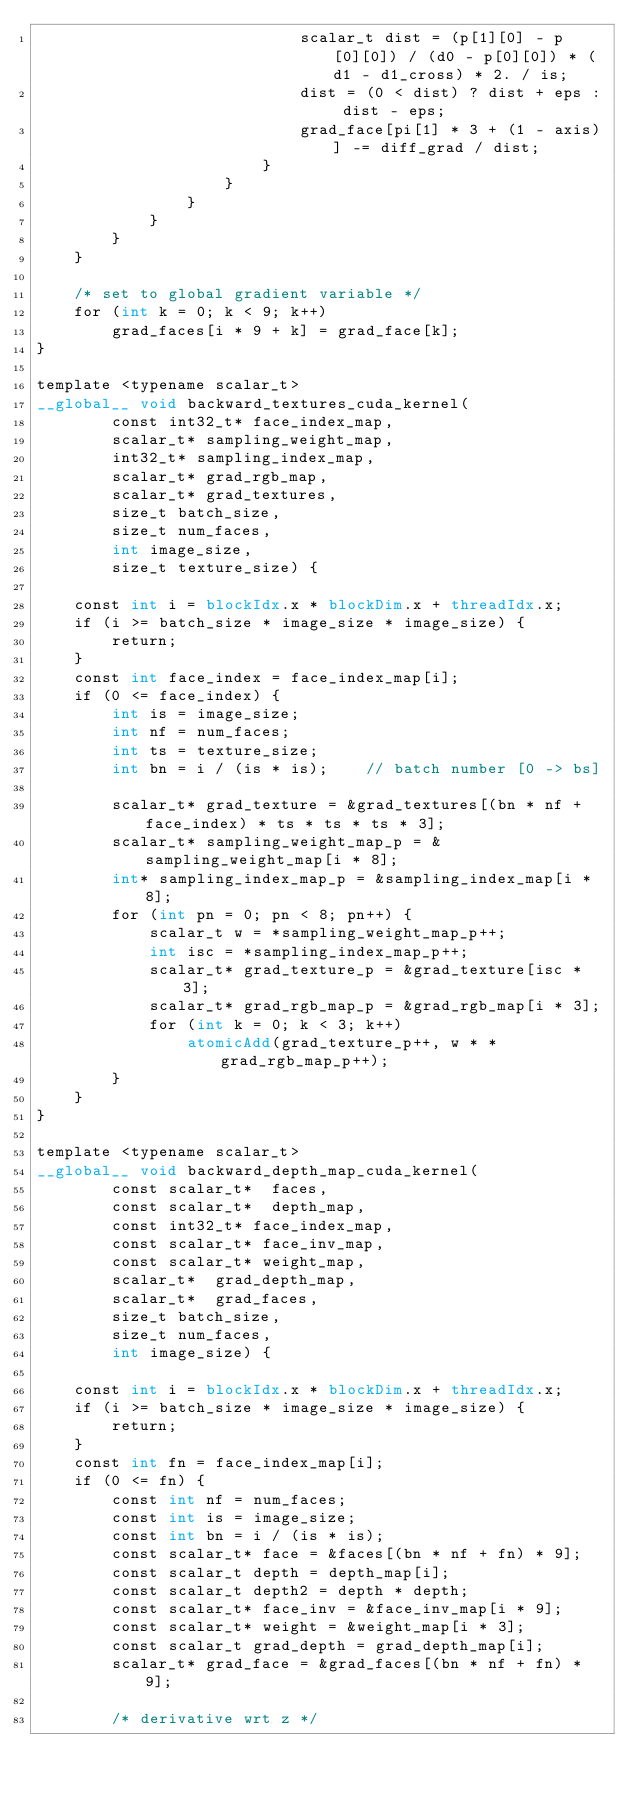<code> <loc_0><loc_0><loc_500><loc_500><_Cuda_>                            scalar_t dist = (p[1][0] - p[0][0]) / (d0 - p[0][0]) * (d1 - d1_cross) * 2. / is;
                            dist = (0 < dist) ? dist + eps : dist - eps;
                            grad_face[pi[1] * 3 + (1 - axis)] -= diff_grad / dist;
                        }
                    }
                }
            }
        }
    }

    /* set to global gradient variable */
    for (int k = 0; k < 9; k++)
        grad_faces[i * 9 + k] = grad_face[k];
}

template <typename scalar_t>
__global__ void backward_textures_cuda_kernel(
        const int32_t* face_index_map,
        scalar_t* sampling_weight_map,
        int32_t* sampling_index_map,
        scalar_t* grad_rgb_map,
        scalar_t* grad_textures,
        size_t batch_size,
        size_t num_faces,
        int image_size,
        size_t texture_size) {

    const int i = blockIdx.x * blockDim.x + threadIdx.x;
    if (i >= batch_size * image_size * image_size) {
        return;
    }
    const int face_index = face_index_map[i];
    if (0 <= face_index) {
        int is = image_size;
        int nf = num_faces;
        int ts = texture_size;
        int bn = i / (is * is);    // batch number [0 -> bs]
    
        scalar_t* grad_texture = &grad_textures[(bn * nf + face_index) * ts * ts * ts * 3];
        scalar_t* sampling_weight_map_p = &sampling_weight_map[i * 8];
        int* sampling_index_map_p = &sampling_index_map[i * 8];
        for (int pn = 0; pn < 8; pn++) {
            scalar_t w = *sampling_weight_map_p++;
            int isc = *sampling_index_map_p++;
            scalar_t* grad_texture_p = &grad_texture[isc * 3];
            scalar_t* grad_rgb_map_p = &grad_rgb_map[i * 3];
            for (int k = 0; k < 3; k++)
                atomicAdd(grad_texture_p++, w * *grad_rgb_map_p++);
        }
    }
}

template <typename scalar_t>
__global__ void backward_depth_map_cuda_kernel(
        const scalar_t*  faces,
        const scalar_t*  depth_map,
        const int32_t* face_index_map,
        const scalar_t* face_inv_map,
        const scalar_t* weight_map,
        scalar_t*  grad_depth_map,
        scalar_t*  grad_faces,
        size_t batch_size,
        size_t num_faces,
        int image_size) {
    
    const int i = blockIdx.x * blockDim.x + threadIdx.x;
    if (i >= batch_size * image_size * image_size) {
        return;
    }
    const int fn = face_index_map[i];
    if (0 <= fn) {
        const int nf = num_faces;
        const int is = image_size;
        const int bn = i / (is * is);
        const scalar_t* face = &faces[(bn * nf + fn) * 9];
        const scalar_t depth = depth_map[i];
        const scalar_t depth2 = depth * depth;
        const scalar_t* face_inv = &face_inv_map[i * 9];
        const scalar_t* weight = &weight_map[i * 3];
        const scalar_t grad_depth = grad_depth_map[i];
        scalar_t* grad_face = &grad_faces[(bn * nf + fn) * 9];
    
        /* derivative wrt z */</code> 